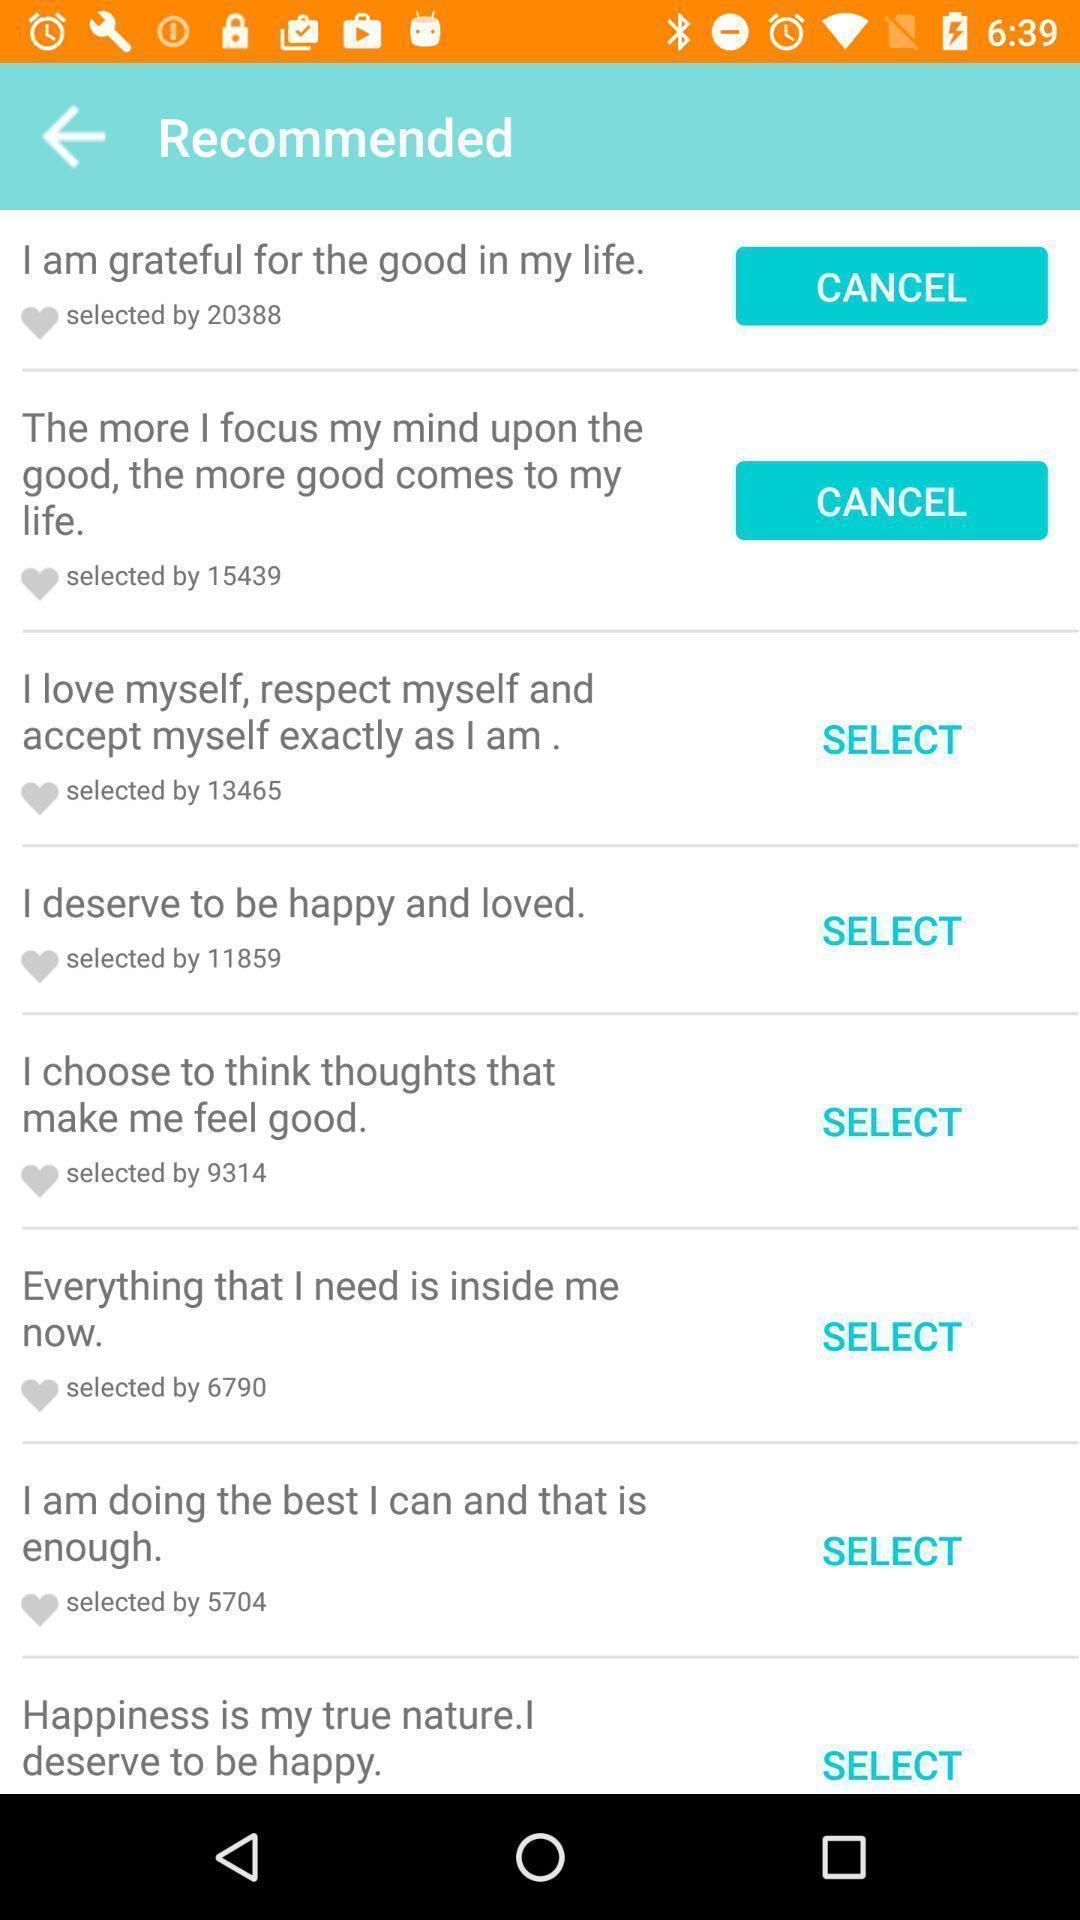Explain the elements present in this screenshot. Screen page displaying various positive quotes. 